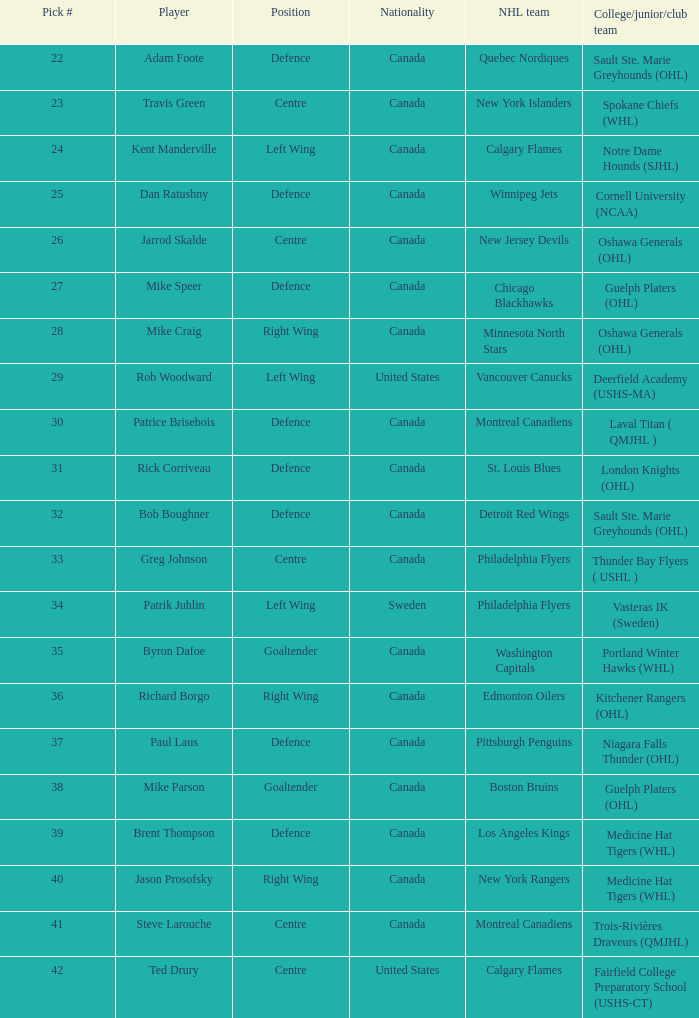What NHL team picked richard borgo? Edmonton Oilers. 